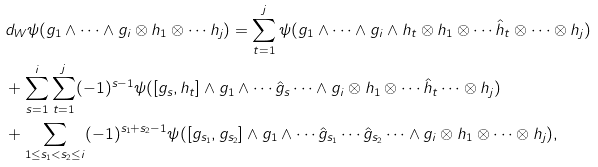<formula> <loc_0><loc_0><loc_500><loc_500>& d _ { W } \psi ( g _ { 1 } \wedge \cdots \wedge g _ { i } \otimes h _ { 1 } \otimes \cdots h _ { j } ) = \sum _ { t = 1 } ^ { j } \psi ( g _ { 1 } \wedge \cdots \wedge g _ { i } \wedge h _ { t } \otimes h _ { 1 } \otimes \cdots \hat { h } _ { t } \otimes \cdots \otimes h _ { j } ) \\ & + \sum _ { s = 1 } ^ { i } \sum _ { t = 1 } ^ { j } ( - 1 ) ^ { s - 1 } \psi ( [ g _ { s } , h _ { t } ] \wedge g _ { 1 } \wedge \cdots \hat { g } _ { s } \cdots \wedge g _ { i } \otimes h _ { 1 } \otimes \cdots \hat { h } _ { t } \cdots \otimes h _ { j } ) \\ & + \sum _ { 1 \leq s _ { 1 } < s _ { 2 } \leq i } ( - 1 ) ^ { s _ { 1 } + s _ { 2 } - 1 } \psi ( [ g _ { s _ { 1 } } , g _ { s _ { 2 } } ] \wedge g _ { 1 } \wedge \cdots \hat { g } _ { s _ { 1 } } \cdots \hat { g } _ { s _ { 2 } } \cdots \wedge g _ { i } \otimes h _ { 1 } \otimes \cdots \otimes h _ { j } ) ,</formula> 